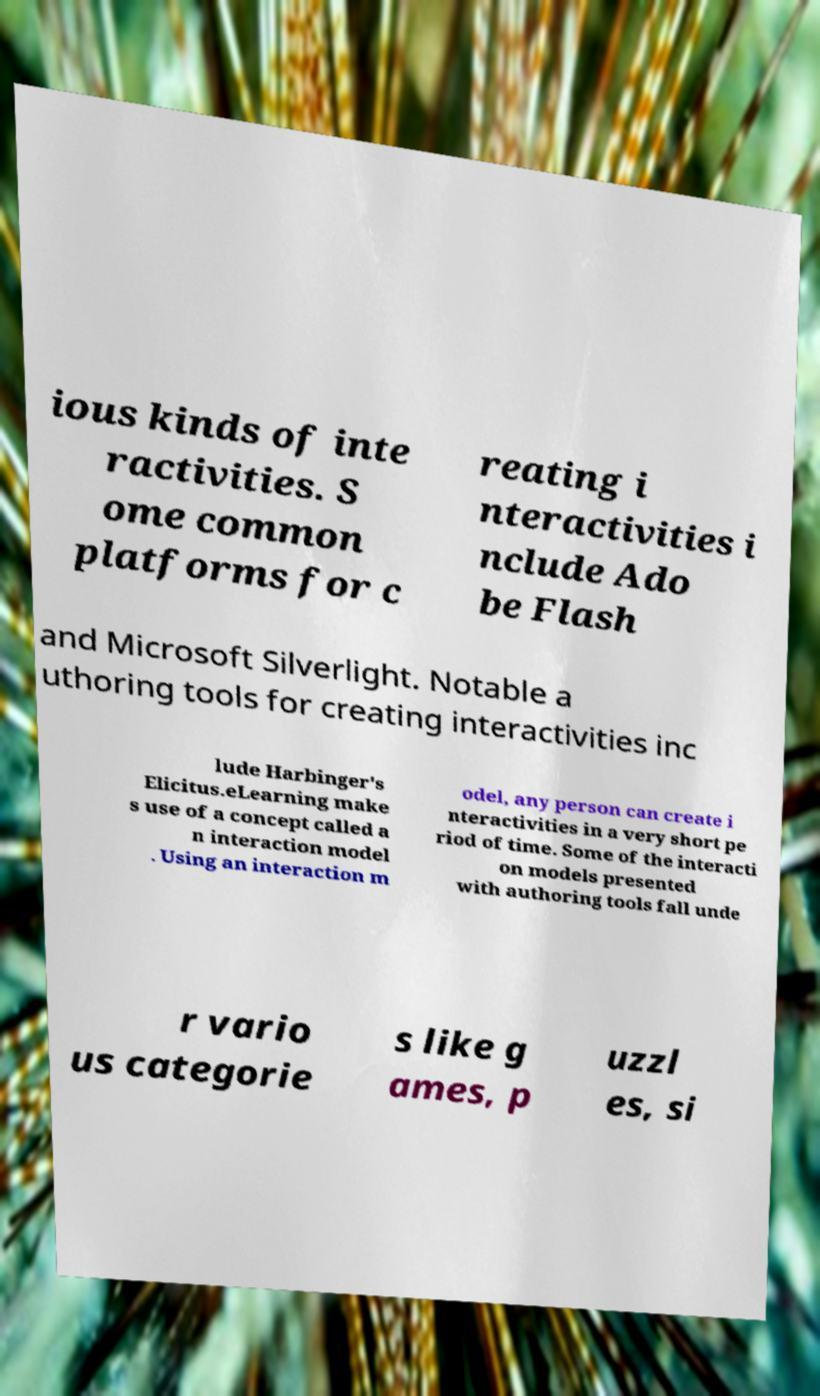Can you accurately transcribe the text from the provided image for me? ious kinds of inte ractivities. S ome common platforms for c reating i nteractivities i nclude Ado be Flash and Microsoft Silverlight. Notable a uthoring tools for creating interactivities inc lude Harbinger's Elicitus.eLearning make s use of a concept called a n interaction model . Using an interaction m odel, any person can create i nteractivities in a very short pe riod of time. Some of the interacti on models presented with authoring tools fall unde r vario us categorie s like g ames, p uzzl es, si 